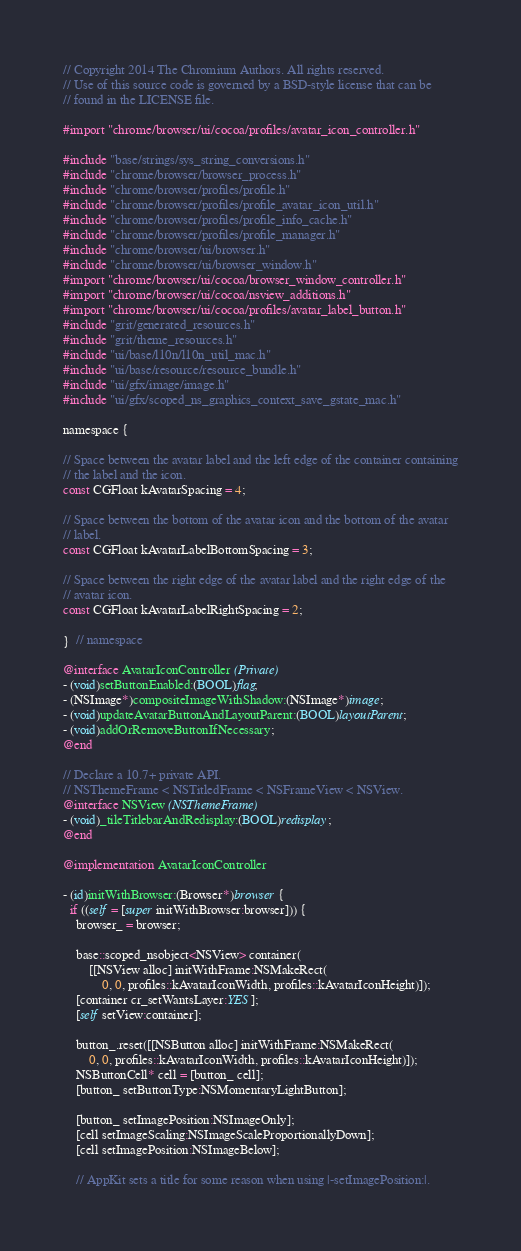Convert code to text. <code><loc_0><loc_0><loc_500><loc_500><_ObjectiveC_>// Copyright 2014 The Chromium Authors. All rights reserved.
// Use of this source code is governed by a BSD-style license that can be
// found in the LICENSE file.

#import "chrome/browser/ui/cocoa/profiles/avatar_icon_controller.h"

#include "base/strings/sys_string_conversions.h"
#include "chrome/browser/browser_process.h"
#include "chrome/browser/profiles/profile.h"
#include "chrome/browser/profiles/profile_avatar_icon_util.h"
#include "chrome/browser/profiles/profile_info_cache.h"
#include "chrome/browser/profiles/profile_manager.h"
#include "chrome/browser/ui/browser.h"
#include "chrome/browser/ui/browser_window.h"
#import "chrome/browser/ui/cocoa/browser_window_controller.h"
#import "chrome/browser/ui/cocoa/nsview_additions.h"
#import "chrome/browser/ui/cocoa/profiles/avatar_label_button.h"
#include "grit/generated_resources.h"
#include "grit/theme_resources.h"
#include "ui/base/l10n/l10n_util_mac.h"
#include "ui/base/resource/resource_bundle.h"
#include "ui/gfx/image/image.h"
#include "ui/gfx/scoped_ns_graphics_context_save_gstate_mac.h"

namespace {

// Space between the avatar label and the left edge of the container containing
// the label and the icon.
const CGFloat kAvatarSpacing = 4;

// Space between the bottom of the avatar icon and the bottom of the avatar
// label.
const CGFloat kAvatarLabelBottomSpacing = 3;

// Space between the right edge of the avatar label and the right edge of the
// avatar icon.
const CGFloat kAvatarLabelRightSpacing = 2;

}  // namespace

@interface AvatarIconController (Private)
- (void)setButtonEnabled:(BOOL)flag;
- (NSImage*)compositeImageWithShadow:(NSImage*)image;
- (void)updateAvatarButtonAndLayoutParent:(BOOL)layoutParent;
- (void)addOrRemoveButtonIfNecessary;
@end

// Declare a 10.7+ private API.
// NSThemeFrame < NSTitledFrame < NSFrameView < NSView.
@interface NSView (NSThemeFrame)
- (void)_tileTitlebarAndRedisplay:(BOOL)redisplay;
@end

@implementation AvatarIconController

- (id)initWithBrowser:(Browser*)browser {
  if ((self = [super initWithBrowser:browser])) {
    browser_ = browser;

    base::scoped_nsobject<NSView> container(
        [[NSView alloc] initWithFrame:NSMakeRect(
            0, 0, profiles::kAvatarIconWidth, profiles::kAvatarIconHeight)]);
    [container cr_setWantsLayer:YES];
    [self setView:container];

    button_.reset([[NSButton alloc] initWithFrame:NSMakeRect(
        0, 0, profiles::kAvatarIconWidth, profiles::kAvatarIconHeight)]);
    NSButtonCell* cell = [button_ cell];
    [button_ setButtonType:NSMomentaryLightButton];

    [button_ setImagePosition:NSImageOnly];
    [cell setImageScaling:NSImageScaleProportionallyDown];
    [cell setImagePosition:NSImageBelow];

    // AppKit sets a title for some reason when using |-setImagePosition:|.</code> 